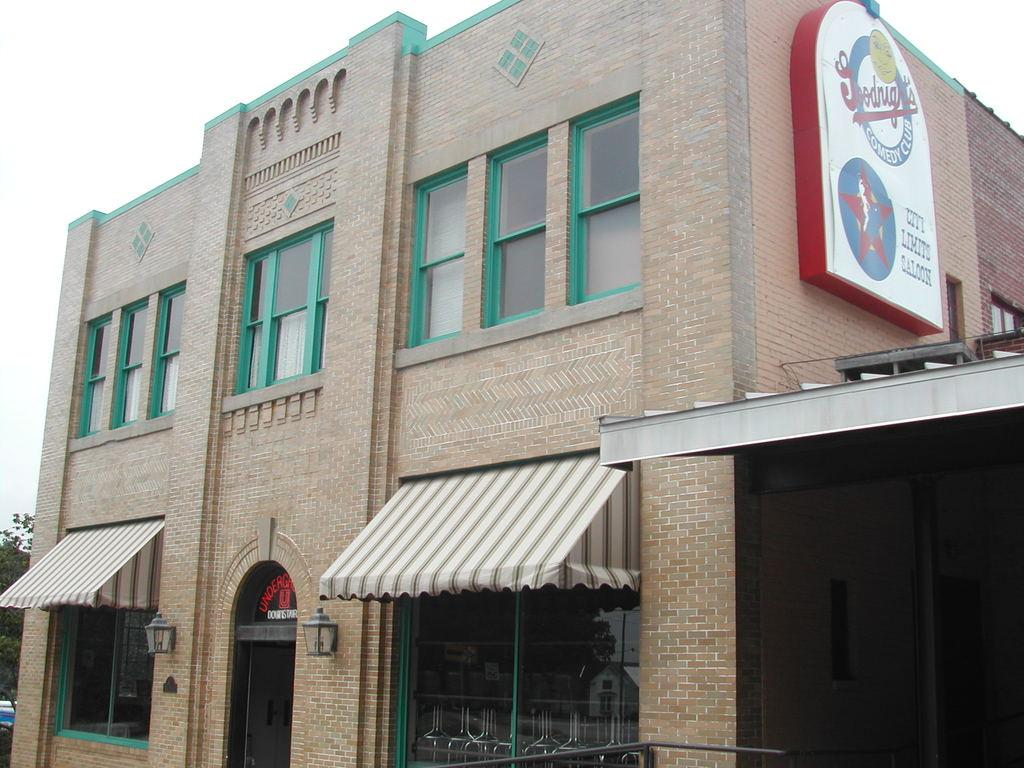What is located in the foreground of the image? There is a building and a board in the foreground of the image. What can be seen on the wall in the foreground of the image? There are two lamps on the wall in the foreground of the image. What is visible in the background of the image? There are trees and the sky visible in the background of the image. Can you tell me how many toads are sitting on the board in the image? There are no toads present in the image; the board is empty. What type of drink is being served by the judge in the image? There is no judge or drink present in the image. 